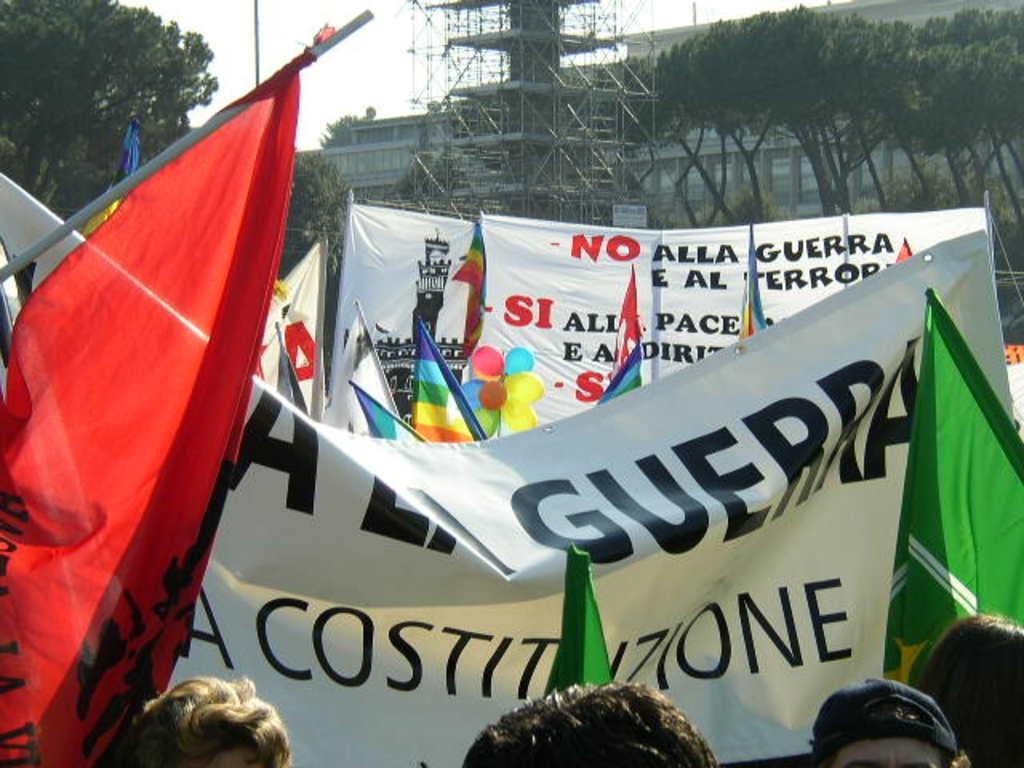Could you give a brief overview of what you see in this image? In this image I can see many flags, balloons and banners. And these banners and flags are colorful. I can see the heads of four people. In the background I can see the tower, many trees, building and the sky. 